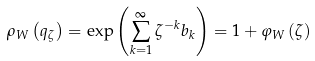Convert formula to latex. <formula><loc_0><loc_0><loc_500><loc_500>\rho _ { W } \left ( q _ { \zeta } \right ) = \exp \left ( \sum _ { k = 1 } ^ { \infty } \zeta ^ { - k } b _ { k } \right ) = 1 + \varphi _ { W } \left ( \zeta \right )</formula> 